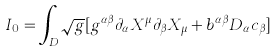<formula> <loc_0><loc_0><loc_500><loc_500>I _ { 0 } = \int _ { D } { \sqrt { g } } [ g ^ { \alpha \beta } \partial _ { \alpha } X ^ { \mu } \partial _ { \beta } X _ { \mu } + b ^ { \alpha \beta } D _ { \alpha } c _ { \beta } ]</formula> 